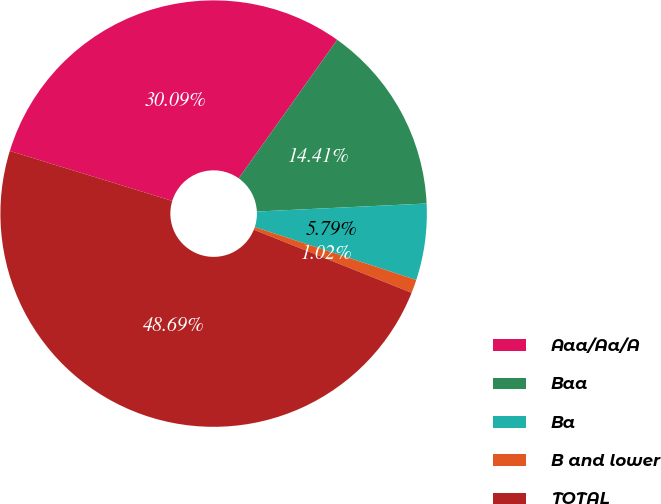Convert chart. <chart><loc_0><loc_0><loc_500><loc_500><pie_chart><fcel>Aaa/Aa/A<fcel>Baa<fcel>Ba<fcel>B and lower<fcel>TOTAL<nl><fcel>30.09%<fcel>14.41%<fcel>5.79%<fcel>1.02%<fcel>48.69%<nl></chart> 